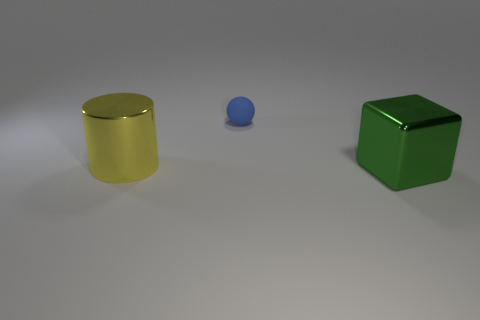Add 2 big shiny cubes. How many objects exist? 5 Add 1 small blue rubber objects. How many small blue rubber objects are left? 2 Add 1 large gray rubber blocks. How many large gray rubber blocks exist? 1 Subtract 0 red cubes. How many objects are left? 3 Subtract all spheres. How many objects are left? 2 Subtract all large green shiny things. Subtract all cylinders. How many objects are left? 1 